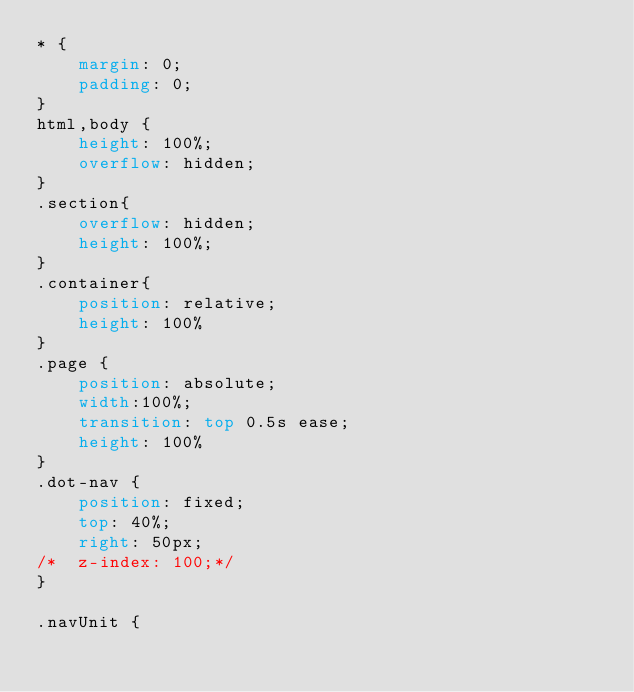Convert code to text. <code><loc_0><loc_0><loc_500><loc_500><_CSS_>* {
	margin: 0;
	padding: 0;
}
html,body {
	height: 100%;
	overflow: hidden;
}
.section{
    overflow: hidden;
    height: 100%;
}
.container{
	position: relative;
	height: 100%
}
.page {
	position: absolute;
	width:100%;
	transition: top 0.5s ease;
	height: 100%
}
.dot-nav {
	position: fixed;
	top: 40%;
	right: 50px;
/*	z-index: 100;*/
}

.navUnit {</code> 